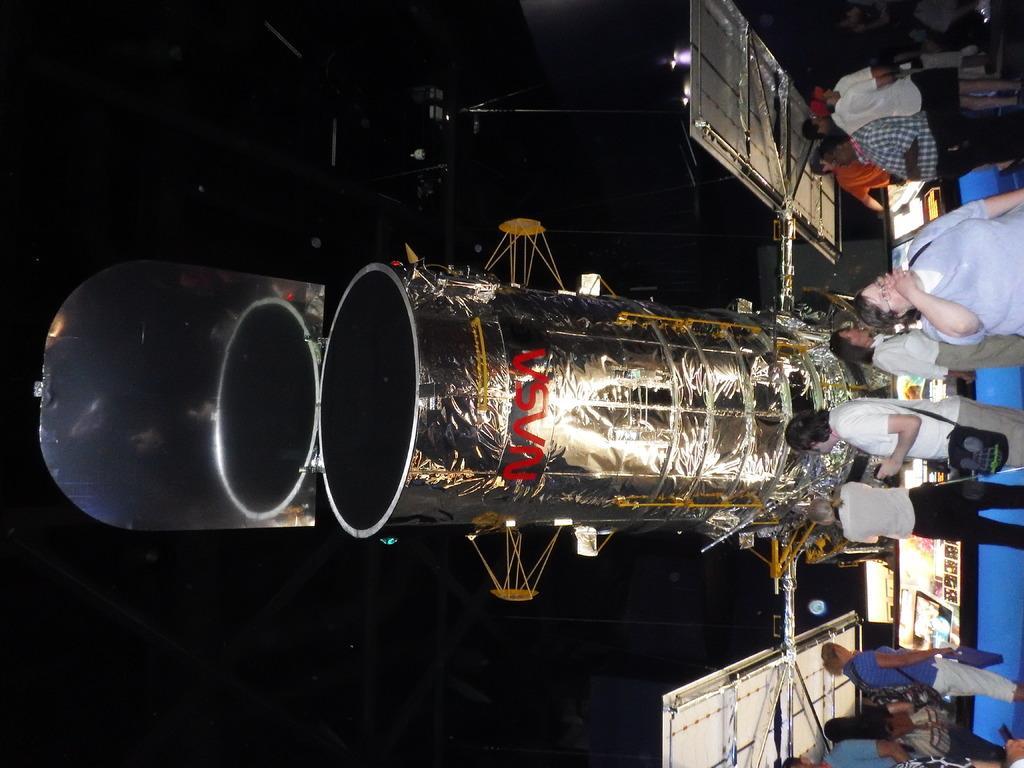In one or two sentences, can you explain what this image depicts? In this picture there are people and we can see space telescope and screens. In the background of the image it is dark. 